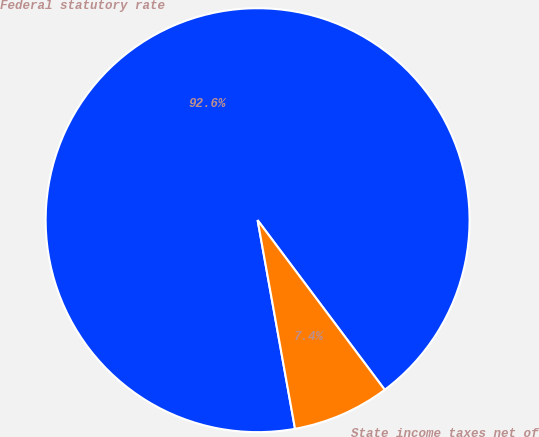<chart> <loc_0><loc_0><loc_500><loc_500><pie_chart><fcel>Federal statutory rate<fcel>State income taxes net of<nl><fcel>92.59%<fcel>7.41%<nl></chart> 